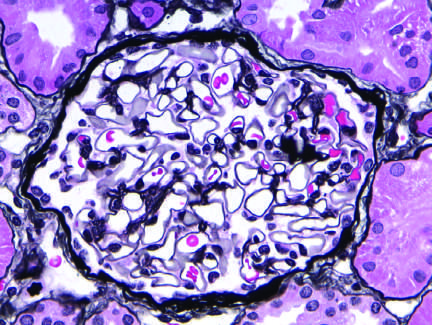does a peripheral blood smear appear normal, with a delicate basement membrane?
Answer the question using a single word or phrase. No 